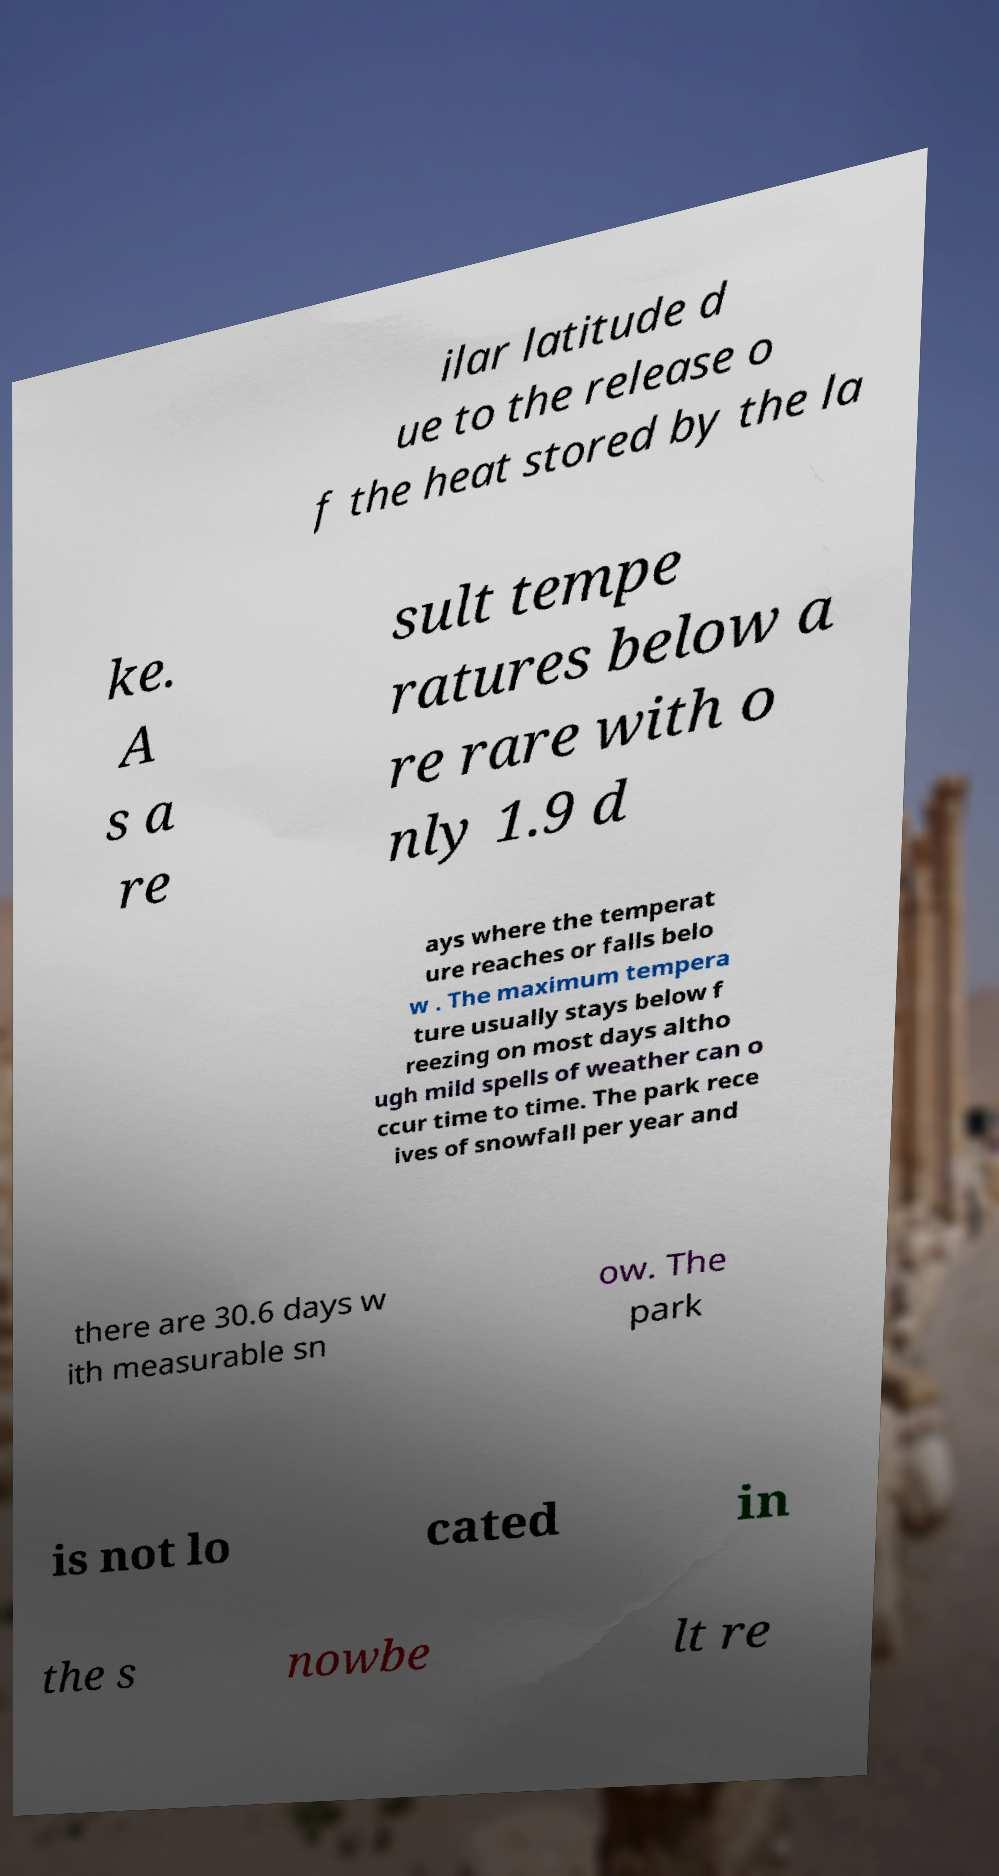Could you extract and type out the text from this image? ilar latitude d ue to the release o f the heat stored by the la ke. A s a re sult tempe ratures below a re rare with o nly 1.9 d ays where the temperat ure reaches or falls belo w . The maximum tempera ture usually stays below f reezing on most days altho ugh mild spells of weather can o ccur time to time. The park rece ives of snowfall per year and there are 30.6 days w ith measurable sn ow. The park is not lo cated in the s nowbe lt re 